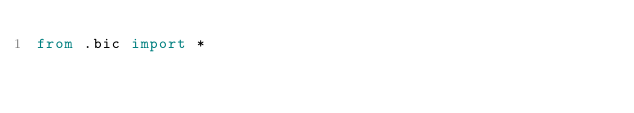Convert code to text. <code><loc_0><loc_0><loc_500><loc_500><_Python_>from .bic import *
</code> 